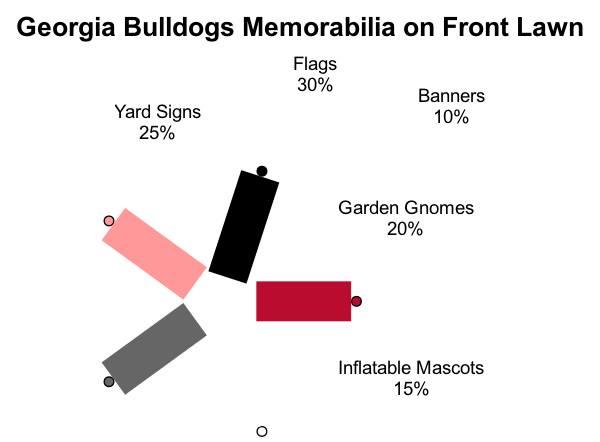What type of memorabilia has the largest percentage? The diagram shows that flags make up 30% of the total displayed memorabilia on the front lawn, which is the highest percentage among all other types.
Answer: Flags What percentage of the memorabilia is represented by inflatable mascots? Inflatable mascots account for 15% of the total memorabilia, as indicated in the pie chart.
Answer: 15% How many types of memorabilia are displayed? The diagram outlines five different types of memorabilia: flags, garden gnomes, yard signs, inflatable mascots, and banners, thus there are five types displayed.
Answer: Five Which type of memorabilia has the smallest representation? The smallest percentage is for banners at 10%, which is the lowest value in the chart, indicating its minimal presence compared to the others.
Answer: Banners What is the combined percentage of yard signs and garden gnomes? Garden gnomes contribute 20% and yard signs 25%, so their combined percentage is 20% + 25% = 45%. This requires adding their respective values from the pie chart to get the total.
Answer: 45% How much percentage do flags and yard signs make together? Flags are 30% and yard signs are 25%, so together their total is 30% + 25% = 55%. This involves another addition of the two categories for the final result.
Answer: 55% How many colors are used in the pie chart? The color scheme provided lists five different colors, each corresponding to a type of memorabilia, therefore there are five colors used in the diagram.
Answer: Five Which type of memorabilia occupies the second largest slice? The second largest slice belongs to yard signs, at 25%. After flags (30%), yard signs are next in size on the pie chart.
Answer: Yard Signs What color represents garden gnomes? The color scheme shows that garden gnomes are represented by the color black, which is the second color in the list associated with that type of memorabilia.
Answer: Black 